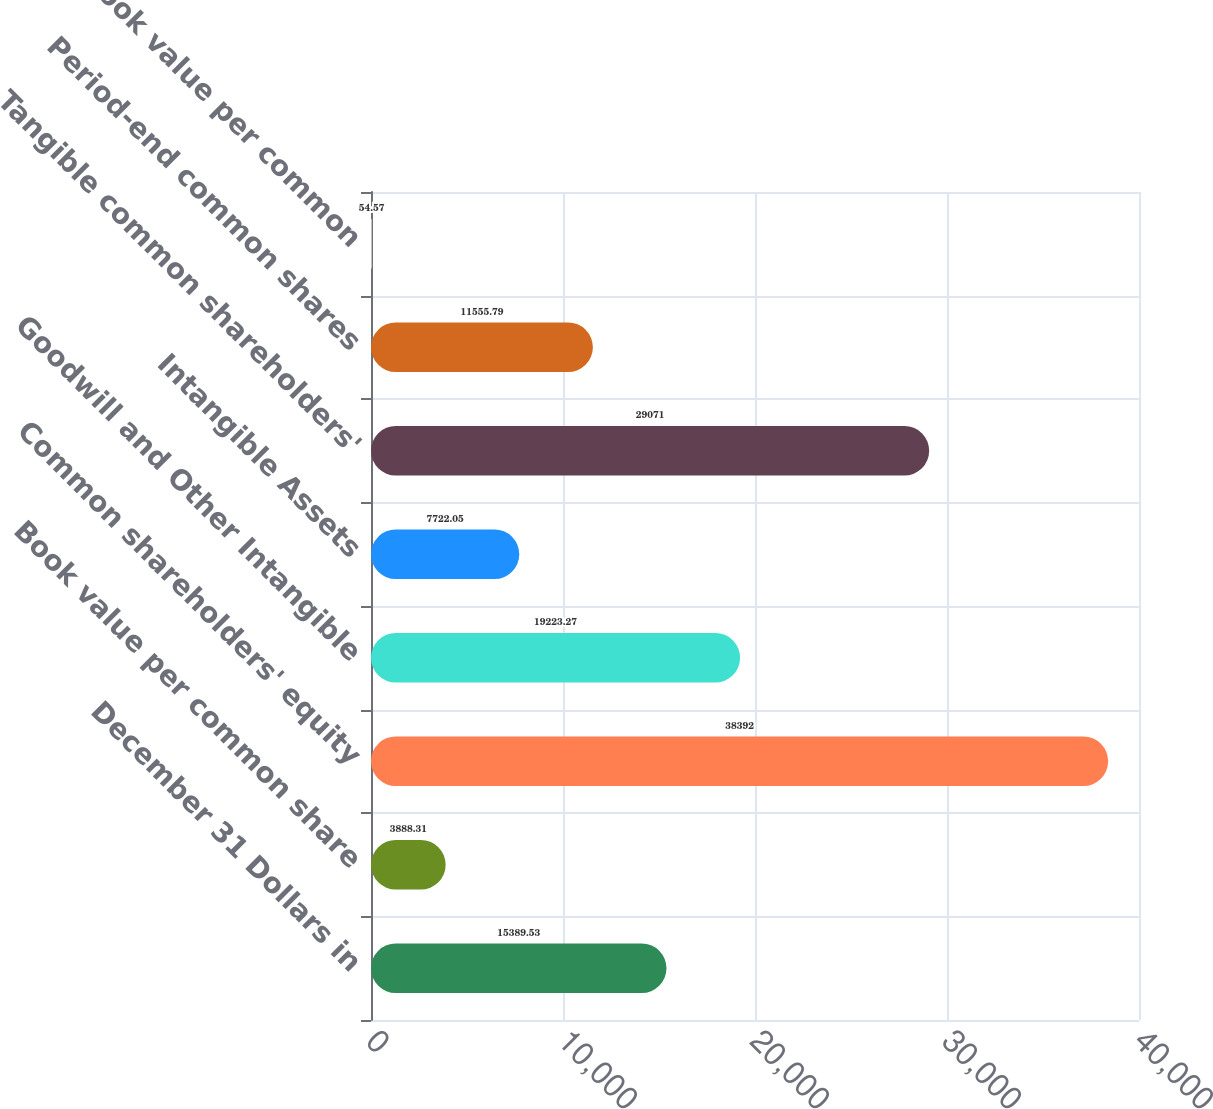Convert chart to OTSL. <chart><loc_0><loc_0><loc_500><loc_500><bar_chart><fcel>December 31 Dollars in<fcel>Book value per common share<fcel>Common shareholders' equity<fcel>Goodwill and Other Intangible<fcel>Intangible Assets<fcel>Tangible common shareholders'<fcel>Period-end common shares<fcel>Tangible book value per common<nl><fcel>15389.5<fcel>3888.31<fcel>38392<fcel>19223.3<fcel>7722.05<fcel>29071<fcel>11555.8<fcel>54.57<nl></chart> 